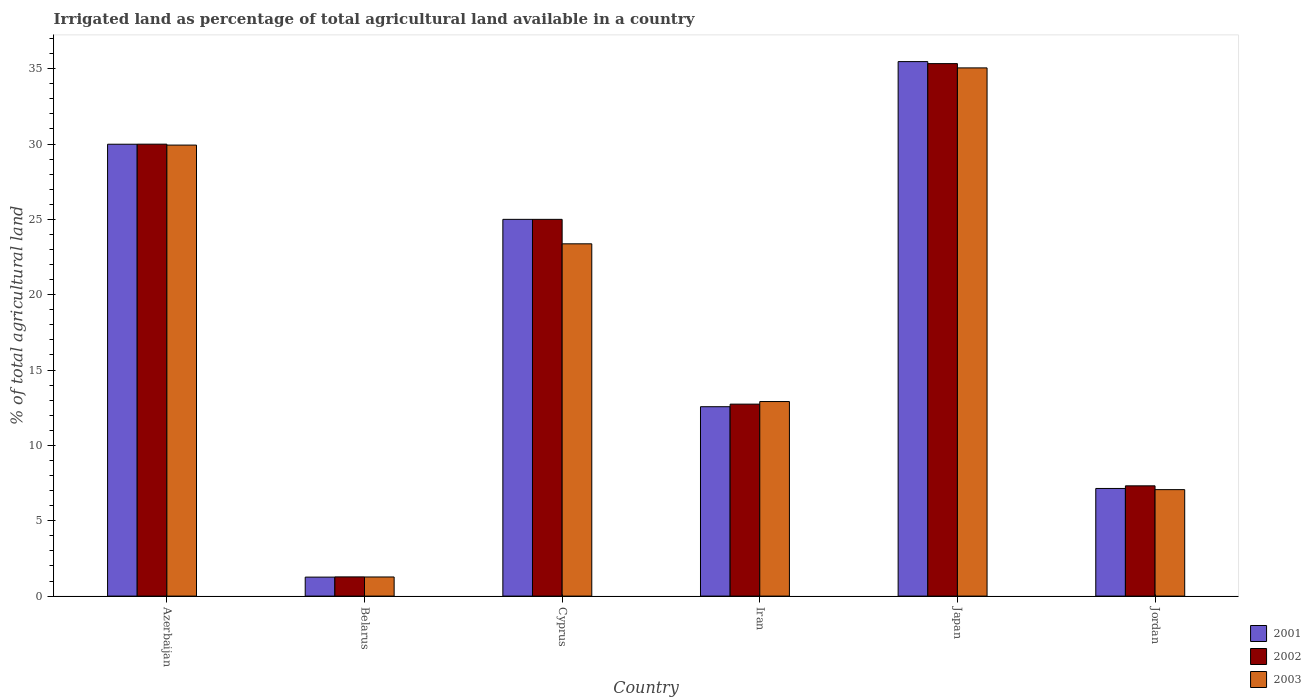How many different coloured bars are there?
Make the answer very short. 3. Are the number of bars on each tick of the X-axis equal?
Offer a very short reply. Yes. How many bars are there on the 6th tick from the right?
Offer a terse response. 3. What is the label of the 1st group of bars from the left?
Provide a succinct answer. Azerbaijan. In how many cases, is the number of bars for a given country not equal to the number of legend labels?
Ensure brevity in your answer.  0. What is the percentage of irrigated land in 2003 in Jordan?
Your response must be concise. 7.06. Across all countries, what is the maximum percentage of irrigated land in 2003?
Provide a short and direct response. 35.05. Across all countries, what is the minimum percentage of irrigated land in 2003?
Give a very brief answer. 1.27. In which country was the percentage of irrigated land in 2003 minimum?
Provide a short and direct response. Belarus. What is the total percentage of irrigated land in 2002 in the graph?
Provide a succinct answer. 111.65. What is the difference between the percentage of irrigated land in 2003 in Iran and that in Japan?
Ensure brevity in your answer.  -22.14. What is the difference between the percentage of irrigated land in 2001 in Cyprus and the percentage of irrigated land in 2002 in Azerbaijan?
Offer a terse response. -4.99. What is the average percentage of irrigated land in 2002 per country?
Your answer should be compact. 18.61. What is the difference between the percentage of irrigated land of/in 2001 and percentage of irrigated land of/in 2002 in Azerbaijan?
Your answer should be very brief. -0. What is the ratio of the percentage of irrigated land in 2003 in Belarus to that in Japan?
Make the answer very short. 0.04. Is the percentage of irrigated land in 2001 in Belarus less than that in Jordan?
Keep it short and to the point. Yes. What is the difference between the highest and the second highest percentage of irrigated land in 2001?
Your answer should be very brief. -10.47. What is the difference between the highest and the lowest percentage of irrigated land in 2003?
Offer a very short reply. 33.78. In how many countries, is the percentage of irrigated land in 2003 greater than the average percentage of irrigated land in 2003 taken over all countries?
Your answer should be compact. 3. What does the 2nd bar from the left in Jordan represents?
Give a very brief answer. 2002. How many bars are there?
Provide a succinct answer. 18. What is the difference between two consecutive major ticks on the Y-axis?
Offer a terse response. 5. Are the values on the major ticks of Y-axis written in scientific E-notation?
Offer a very short reply. No. Does the graph contain any zero values?
Ensure brevity in your answer.  No. Where does the legend appear in the graph?
Your answer should be very brief. Bottom right. What is the title of the graph?
Your answer should be very brief. Irrigated land as percentage of total agricultural land available in a country. What is the label or title of the X-axis?
Offer a very short reply. Country. What is the label or title of the Y-axis?
Keep it short and to the point. % of total agricultural land. What is the % of total agricultural land in 2001 in Azerbaijan?
Provide a succinct answer. 29.99. What is the % of total agricultural land of 2002 in Azerbaijan?
Provide a succinct answer. 29.99. What is the % of total agricultural land of 2003 in Azerbaijan?
Offer a very short reply. 29.93. What is the % of total agricultural land in 2001 in Belarus?
Give a very brief answer. 1.26. What is the % of total agricultural land in 2002 in Belarus?
Offer a very short reply. 1.27. What is the % of total agricultural land of 2003 in Belarus?
Your response must be concise. 1.27. What is the % of total agricultural land in 2002 in Cyprus?
Offer a very short reply. 25. What is the % of total agricultural land in 2003 in Cyprus?
Ensure brevity in your answer.  23.38. What is the % of total agricultural land of 2001 in Iran?
Your answer should be very brief. 12.57. What is the % of total agricultural land in 2002 in Iran?
Make the answer very short. 12.74. What is the % of total agricultural land of 2003 in Iran?
Your response must be concise. 12.91. What is the % of total agricultural land of 2001 in Japan?
Provide a succinct answer. 35.47. What is the % of total agricultural land in 2002 in Japan?
Keep it short and to the point. 35.33. What is the % of total agricultural land in 2003 in Japan?
Offer a very short reply. 35.05. What is the % of total agricultural land of 2001 in Jordan?
Provide a succinct answer. 7.14. What is the % of total agricultural land of 2002 in Jordan?
Your answer should be very brief. 7.32. What is the % of total agricultural land in 2003 in Jordan?
Make the answer very short. 7.06. Across all countries, what is the maximum % of total agricultural land of 2001?
Offer a very short reply. 35.47. Across all countries, what is the maximum % of total agricultural land in 2002?
Offer a terse response. 35.33. Across all countries, what is the maximum % of total agricultural land of 2003?
Give a very brief answer. 35.05. Across all countries, what is the minimum % of total agricultural land of 2001?
Make the answer very short. 1.26. Across all countries, what is the minimum % of total agricultural land of 2002?
Your answer should be compact. 1.27. Across all countries, what is the minimum % of total agricultural land in 2003?
Your answer should be very brief. 1.27. What is the total % of total agricultural land of 2001 in the graph?
Your response must be concise. 111.42. What is the total % of total agricultural land in 2002 in the graph?
Give a very brief answer. 111.65. What is the total % of total agricultural land in 2003 in the graph?
Offer a terse response. 109.6. What is the difference between the % of total agricultural land of 2001 in Azerbaijan and that in Belarus?
Keep it short and to the point. 28.73. What is the difference between the % of total agricultural land of 2002 in Azerbaijan and that in Belarus?
Your response must be concise. 28.72. What is the difference between the % of total agricultural land of 2003 in Azerbaijan and that in Belarus?
Provide a short and direct response. 28.66. What is the difference between the % of total agricultural land of 2001 in Azerbaijan and that in Cyprus?
Provide a succinct answer. 4.99. What is the difference between the % of total agricultural land of 2002 in Azerbaijan and that in Cyprus?
Your response must be concise. 4.99. What is the difference between the % of total agricultural land in 2003 in Azerbaijan and that in Cyprus?
Your answer should be compact. 6.55. What is the difference between the % of total agricultural land in 2001 in Azerbaijan and that in Iran?
Ensure brevity in your answer.  17.42. What is the difference between the % of total agricultural land in 2002 in Azerbaijan and that in Iran?
Keep it short and to the point. 17.25. What is the difference between the % of total agricultural land in 2003 in Azerbaijan and that in Iran?
Offer a terse response. 17.02. What is the difference between the % of total agricultural land in 2001 in Azerbaijan and that in Japan?
Offer a terse response. -5.48. What is the difference between the % of total agricultural land in 2002 in Azerbaijan and that in Japan?
Provide a succinct answer. -5.34. What is the difference between the % of total agricultural land in 2003 in Azerbaijan and that in Japan?
Offer a terse response. -5.12. What is the difference between the % of total agricultural land of 2001 in Azerbaijan and that in Jordan?
Ensure brevity in your answer.  22.84. What is the difference between the % of total agricultural land of 2002 in Azerbaijan and that in Jordan?
Keep it short and to the point. 22.67. What is the difference between the % of total agricultural land of 2003 in Azerbaijan and that in Jordan?
Ensure brevity in your answer.  22.86. What is the difference between the % of total agricultural land of 2001 in Belarus and that in Cyprus?
Your answer should be compact. -23.74. What is the difference between the % of total agricultural land in 2002 in Belarus and that in Cyprus?
Provide a short and direct response. -23.73. What is the difference between the % of total agricultural land in 2003 in Belarus and that in Cyprus?
Give a very brief answer. -22.11. What is the difference between the % of total agricultural land in 2001 in Belarus and that in Iran?
Offer a very short reply. -11.31. What is the difference between the % of total agricultural land in 2002 in Belarus and that in Iran?
Ensure brevity in your answer.  -11.46. What is the difference between the % of total agricultural land of 2003 in Belarus and that in Iran?
Your response must be concise. -11.64. What is the difference between the % of total agricultural land in 2001 in Belarus and that in Japan?
Your response must be concise. -34.21. What is the difference between the % of total agricultural land in 2002 in Belarus and that in Japan?
Keep it short and to the point. -34.06. What is the difference between the % of total agricultural land of 2003 in Belarus and that in Japan?
Your response must be concise. -33.78. What is the difference between the % of total agricultural land of 2001 in Belarus and that in Jordan?
Your response must be concise. -5.88. What is the difference between the % of total agricultural land in 2002 in Belarus and that in Jordan?
Make the answer very short. -6.04. What is the difference between the % of total agricultural land in 2003 in Belarus and that in Jordan?
Provide a succinct answer. -5.8. What is the difference between the % of total agricultural land of 2001 in Cyprus and that in Iran?
Offer a very short reply. 12.43. What is the difference between the % of total agricultural land of 2002 in Cyprus and that in Iran?
Provide a short and direct response. 12.26. What is the difference between the % of total agricultural land in 2003 in Cyprus and that in Iran?
Offer a terse response. 10.47. What is the difference between the % of total agricultural land in 2001 in Cyprus and that in Japan?
Provide a succinct answer. -10.47. What is the difference between the % of total agricultural land of 2002 in Cyprus and that in Japan?
Provide a succinct answer. -10.33. What is the difference between the % of total agricultural land of 2003 in Cyprus and that in Japan?
Ensure brevity in your answer.  -11.67. What is the difference between the % of total agricultural land of 2001 in Cyprus and that in Jordan?
Offer a very short reply. 17.86. What is the difference between the % of total agricultural land of 2002 in Cyprus and that in Jordan?
Your response must be concise. 17.68. What is the difference between the % of total agricultural land in 2003 in Cyprus and that in Jordan?
Keep it short and to the point. 16.31. What is the difference between the % of total agricultural land in 2001 in Iran and that in Japan?
Your answer should be very brief. -22.9. What is the difference between the % of total agricultural land of 2002 in Iran and that in Japan?
Offer a terse response. -22.6. What is the difference between the % of total agricultural land in 2003 in Iran and that in Japan?
Offer a terse response. -22.14. What is the difference between the % of total agricultural land of 2001 in Iran and that in Jordan?
Offer a terse response. 5.42. What is the difference between the % of total agricultural land of 2002 in Iran and that in Jordan?
Provide a succinct answer. 5.42. What is the difference between the % of total agricultural land in 2003 in Iran and that in Jordan?
Make the answer very short. 5.85. What is the difference between the % of total agricultural land in 2001 in Japan and that in Jordan?
Provide a short and direct response. 28.33. What is the difference between the % of total agricultural land in 2002 in Japan and that in Jordan?
Give a very brief answer. 28.02. What is the difference between the % of total agricultural land in 2003 in Japan and that in Jordan?
Your answer should be compact. 27.99. What is the difference between the % of total agricultural land of 2001 in Azerbaijan and the % of total agricultural land of 2002 in Belarus?
Keep it short and to the point. 28.71. What is the difference between the % of total agricultural land of 2001 in Azerbaijan and the % of total agricultural land of 2003 in Belarus?
Offer a very short reply. 28.72. What is the difference between the % of total agricultural land of 2002 in Azerbaijan and the % of total agricultural land of 2003 in Belarus?
Your response must be concise. 28.72. What is the difference between the % of total agricultural land of 2001 in Azerbaijan and the % of total agricultural land of 2002 in Cyprus?
Provide a succinct answer. 4.99. What is the difference between the % of total agricultural land in 2001 in Azerbaijan and the % of total agricultural land in 2003 in Cyprus?
Your answer should be compact. 6.61. What is the difference between the % of total agricultural land in 2002 in Azerbaijan and the % of total agricultural land in 2003 in Cyprus?
Offer a very short reply. 6.61. What is the difference between the % of total agricultural land in 2001 in Azerbaijan and the % of total agricultural land in 2002 in Iran?
Offer a very short reply. 17.25. What is the difference between the % of total agricultural land in 2001 in Azerbaijan and the % of total agricultural land in 2003 in Iran?
Offer a terse response. 17.08. What is the difference between the % of total agricultural land in 2002 in Azerbaijan and the % of total agricultural land in 2003 in Iran?
Your answer should be very brief. 17.08. What is the difference between the % of total agricultural land in 2001 in Azerbaijan and the % of total agricultural land in 2002 in Japan?
Ensure brevity in your answer.  -5.35. What is the difference between the % of total agricultural land in 2001 in Azerbaijan and the % of total agricultural land in 2003 in Japan?
Keep it short and to the point. -5.07. What is the difference between the % of total agricultural land of 2002 in Azerbaijan and the % of total agricultural land of 2003 in Japan?
Offer a terse response. -5.06. What is the difference between the % of total agricultural land of 2001 in Azerbaijan and the % of total agricultural land of 2002 in Jordan?
Provide a succinct answer. 22.67. What is the difference between the % of total agricultural land of 2001 in Azerbaijan and the % of total agricultural land of 2003 in Jordan?
Make the answer very short. 22.92. What is the difference between the % of total agricultural land of 2002 in Azerbaijan and the % of total agricultural land of 2003 in Jordan?
Your answer should be compact. 22.93. What is the difference between the % of total agricultural land in 2001 in Belarus and the % of total agricultural land in 2002 in Cyprus?
Your answer should be compact. -23.74. What is the difference between the % of total agricultural land in 2001 in Belarus and the % of total agricultural land in 2003 in Cyprus?
Provide a short and direct response. -22.12. What is the difference between the % of total agricultural land of 2002 in Belarus and the % of total agricultural land of 2003 in Cyprus?
Your response must be concise. -22.1. What is the difference between the % of total agricultural land of 2001 in Belarus and the % of total agricultural land of 2002 in Iran?
Your answer should be very brief. -11.48. What is the difference between the % of total agricultural land in 2001 in Belarus and the % of total agricultural land in 2003 in Iran?
Your answer should be compact. -11.65. What is the difference between the % of total agricultural land of 2002 in Belarus and the % of total agricultural land of 2003 in Iran?
Ensure brevity in your answer.  -11.64. What is the difference between the % of total agricultural land in 2001 in Belarus and the % of total agricultural land in 2002 in Japan?
Provide a short and direct response. -34.08. What is the difference between the % of total agricultural land in 2001 in Belarus and the % of total agricultural land in 2003 in Japan?
Provide a short and direct response. -33.79. What is the difference between the % of total agricultural land in 2002 in Belarus and the % of total agricultural land in 2003 in Japan?
Your answer should be compact. -33.78. What is the difference between the % of total agricultural land of 2001 in Belarus and the % of total agricultural land of 2002 in Jordan?
Your response must be concise. -6.06. What is the difference between the % of total agricultural land in 2001 in Belarus and the % of total agricultural land in 2003 in Jordan?
Your response must be concise. -5.8. What is the difference between the % of total agricultural land of 2002 in Belarus and the % of total agricultural land of 2003 in Jordan?
Your response must be concise. -5.79. What is the difference between the % of total agricultural land of 2001 in Cyprus and the % of total agricultural land of 2002 in Iran?
Ensure brevity in your answer.  12.26. What is the difference between the % of total agricultural land of 2001 in Cyprus and the % of total agricultural land of 2003 in Iran?
Your answer should be compact. 12.09. What is the difference between the % of total agricultural land in 2002 in Cyprus and the % of total agricultural land in 2003 in Iran?
Your answer should be very brief. 12.09. What is the difference between the % of total agricultural land in 2001 in Cyprus and the % of total agricultural land in 2002 in Japan?
Offer a terse response. -10.33. What is the difference between the % of total agricultural land in 2001 in Cyprus and the % of total agricultural land in 2003 in Japan?
Your answer should be compact. -10.05. What is the difference between the % of total agricultural land in 2002 in Cyprus and the % of total agricultural land in 2003 in Japan?
Provide a short and direct response. -10.05. What is the difference between the % of total agricultural land in 2001 in Cyprus and the % of total agricultural land in 2002 in Jordan?
Your answer should be compact. 17.68. What is the difference between the % of total agricultural land in 2001 in Cyprus and the % of total agricultural land in 2003 in Jordan?
Your response must be concise. 17.94. What is the difference between the % of total agricultural land of 2002 in Cyprus and the % of total agricultural land of 2003 in Jordan?
Your response must be concise. 17.94. What is the difference between the % of total agricultural land of 2001 in Iran and the % of total agricultural land of 2002 in Japan?
Keep it short and to the point. -22.77. What is the difference between the % of total agricultural land of 2001 in Iran and the % of total agricultural land of 2003 in Japan?
Make the answer very short. -22.48. What is the difference between the % of total agricultural land of 2002 in Iran and the % of total agricultural land of 2003 in Japan?
Your response must be concise. -22.31. What is the difference between the % of total agricultural land of 2001 in Iran and the % of total agricultural land of 2002 in Jordan?
Your response must be concise. 5.25. What is the difference between the % of total agricultural land of 2001 in Iran and the % of total agricultural land of 2003 in Jordan?
Provide a short and direct response. 5.5. What is the difference between the % of total agricultural land of 2002 in Iran and the % of total agricultural land of 2003 in Jordan?
Offer a very short reply. 5.67. What is the difference between the % of total agricultural land of 2001 in Japan and the % of total agricultural land of 2002 in Jordan?
Your answer should be very brief. 28.15. What is the difference between the % of total agricultural land of 2001 in Japan and the % of total agricultural land of 2003 in Jordan?
Your answer should be very brief. 28.4. What is the difference between the % of total agricultural land of 2002 in Japan and the % of total agricultural land of 2003 in Jordan?
Ensure brevity in your answer.  28.27. What is the average % of total agricultural land in 2001 per country?
Your answer should be very brief. 18.57. What is the average % of total agricultural land in 2002 per country?
Keep it short and to the point. 18.61. What is the average % of total agricultural land in 2003 per country?
Your answer should be compact. 18.27. What is the difference between the % of total agricultural land of 2001 and % of total agricultural land of 2002 in Azerbaijan?
Offer a terse response. -0. What is the difference between the % of total agricultural land of 2001 and % of total agricultural land of 2003 in Azerbaijan?
Your response must be concise. 0.06. What is the difference between the % of total agricultural land in 2002 and % of total agricultural land in 2003 in Azerbaijan?
Ensure brevity in your answer.  0.06. What is the difference between the % of total agricultural land of 2001 and % of total agricultural land of 2002 in Belarus?
Your response must be concise. -0.01. What is the difference between the % of total agricultural land of 2001 and % of total agricultural land of 2003 in Belarus?
Your answer should be very brief. -0.01. What is the difference between the % of total agricultural land in 2002 and % of total agricultural land in 2003 in Belarus?
Make the answer very short. 0.01. What is the difference between the % of total agricultural land of 2001 and % of total agricultural land of 2003 in Cyprus?
Give a very brief answer. 1.62. What is the difference between the % of total agricultural land in 2002 and % of total agricultural land in 2003 in Cyprus?
Provide a succinct answer. 1.62. What is the difference between the % of total agricultural land of 2001 and % of total agricultural land of 2002 in Iran?
Provide a short and direct response. -0.17. What is the difference between the % of total agricultural land in 2001 and % of total agricultural land in 2003 in Iran?
Offer a very short reply. -0.34. What is the difference between the % of total agricultural land in 2002 and % of total agricultural land in 2003 in Iran?
Your response must be concise. -0.17. What is the difference between the % of total agricultural land in 2001 and % of total agricultural land in 2002 in Japan?
Provide a succinct answer. 0.13. What is the difference between the % of total agricultural land in 2001 and % of total agricultural land in 2003 in Japan?
Provide a succinct answer. 0.42. What is the difference between the % of total agricultural land of 2002 and % of total agricultural land of 2003 in Japan?
Keep it short and to the point. 0.28. What is the difference between the % of total agricultural land in 2001 and % of total agricultural land in 2002 in Jordan?
Ensure brevity in your answer.  -0.17. What is the difference between the % of total agricultural land of 2001 and % of total agricultural land of 2003 in Jordan?
Give a very brief answer. 0.08. What is the difference between the % of total agricultural land of 2002 and % of total agricultural land of 2003 in Jordan?
Your response must be concise. 0.25. What is the ratio of the % of total agricultural land in 2001 in Azerbaijan to that in Belarus?
Provide a succinct answer. 23.8. What is the ratio of the % of total agricultural land of 2002 in Azerbaijan to that in Belarus?
Give a very brief answer. 23.54. What is the ratio of the % of total agricultural land of 2003 in Azerbaijan to that in Belarus?
Your answer should be compact. 23.59. What is the ratio of the % of total agricultural land in 2001 in Azerbaijan to that in Cyprus?
Your answer should be very brief. 1.2. What is the ratio of the % of total agricultural land in 2002 in Azerbaijan to that in Cyprus?
Provide a short and direct response. 1.2. What is the ratio of the % of total agricultural land of 2003 in Azerbaijan to that in Cyprus?
Keep it short and to the point. 1.28. What is the ratio of the % of total agricultural land in 2001 in Azerbaijan to that in Iran?
Ensure brevity in your answer.  2.39. What is the ratio of the % of total agricultural land in 2002 in Azerbaijan to that in Iran?
Your response must be concise. 2.35. What is the ratio of the % of total agricultural land of 2003 in Azerbaijan to that in Iran?
Your answer should be compact. 2.32. What is the ratio of the % of total agricultural land in 2001 in Azerbaijan to that in Japan?
Offer a very short reply. 0.85. What is the ratio of the % of total agricultural land of 2002 in Azerbaijan to that in Japan?
Offer a very short reply. 0.85. What is the ratio of the % of total agricultural land of 2003 in Azerbaijan to that in Japan?
Offer a very short reply. 0.85. What is the ratio of the % of total agricultural land of 2001 in Azerbaijan to that in Jordan?
Ensure brevity in your answer.  4.2. What is the ratio of the % of total agricultural land in 2002 in Azerbaijan to that in Jordan?
Your response must be concise. 4.1. What is the ratio of the % of total agricultural land in 2003 in Azerbaijan to that in Jordan?
Give a very brief answer. 4.24. What is the ratio of the % of total agricultural land in 2001 in Belarus to that in Cyprus?
Your answer should be compact. 0.05. What is the ratio of the % of total agricultural land in 2002 in Belarus to that in Cyprus?
Make the answer very short. 0.05. What is the ratio of the % of total agricultural land in 2003 in Belarus to that in Cyprus?
Your response must be concise. 0.05. What is the ratio of the % of total agricultural land of 2001 in Belarus to that in Iran?
Ensure brevity in your answer.  0.1. What is the ratio of the % of total agricultural land in 2002 in Belarus to that in Iran?
Provide a short and direct response. 0.1. What is the ratio of the % of total agricultural land in 2003 in Belarus to that in Iran?
Offer a very short reply. 0.1. What is the ratio of the % of total agricultural land in 2001 in Belarus to that in Japan?
Your answer should be very brief. 0.04. What is the ratio of the % of total agricultural land in 2002 in Belarus to that in Japan?
Provide a short and direct response. 0.04. What is the ratio of the % of total agricultural land in 2003 in Belarus to that in Japan?
Make the answer very short. 0.04. What is the ratio of the % of total agricultural land in 2001 in Belarus to that in Jordan?
Your answer should be compact. 0.18. What is the ratio of the % of total agricultural land in 2002 in Belarus to that in Jordan?
Your response must be concise. 0.17. What is the ratio of the % of total agricultural land of 2003 in Belarus to that in Jordan?
Your response must be concise. 0.18. What is the ratio of the % of total agricultural land in 2001 in Cyprus to that in Iran?
Make the answer very short. 1.99. What is the ratio of the % of total agricultural land in 2002 in Cyprus to that in Iran?
Provide a succinct answer. 1.96. What is the ratio of the % of total agricultural land in 2003 in Cyprus to that in Iran?
Provide a short and direct response. 1.81. What is the ratio of the % of total agricultural land in 2001 in Cyprus to that in Japan?
Your answer should be compact. 0.7. What is the ratio of the % of total agricultural land of 2002 in Cyprus to that in Japan?
Provide a short and direct response. 0.71. What is the ratio of the % of total agricultural land in 2003 in Cyprus to that in Japan?
Offer a very short reply. 0.67. What is the ratio of the % of total agricultural land in 2001 in Cyprus to that in Jordan?
Give a very brief answer. 3.5. What is the ratio of the % of total agricultural land of 2002 in Cyprus to that in Jordan?
Your answer should be compact. 3.42. What is the ratio of the % of total agricultural land of 2003 in Cyprus to that in Jordan?
Keep it short and to the point. 3.31. What is the ratio of the % of total agricultural land of 2001 in Iran to that in Japan?
Provide a short and direct response. 0.35. What is the ratio of the % of total agricultural land in 2002 in Iran to that in Japan?
Provide a succinct answer. 0.36. What is the ratio of the % of total agricultural land of 2003 in Iran to that in Japan?
Your answer should be very brief. 0.37. What is the ratio of the % of total agricultural land in 2001 in Iran to that in Jordan?
Provide a short and direct response. 1.76. What is the ratio of the % of total agricultural land in 2002 in Iran to that in Jordan?
Offer a very short reply. 1.74. What is the ratio of the % of total agricultural land of 2003 in Iran to that in Jordan?
Offer a very short reply. 1.83. What is the ratio of the % of total agricultural land of 2001 in Japan to that in Jordan?
Your answer should be compact. 4.97. What is the ratio of the % of total agricultural land in 2002 in Japan to that in Jordan?
Keep it short and to the point. 4.83. What is the ratio of the % of total agricultural land in 2003 in Japan to that in Jordan?
Make the answer very short. 4.96. What is the difference between the highest and the second highest % of total agricultural land in 2001?
Offer a very short reply. 5.48. What is the difference between the highest and the second highest % of total agricultural land of 2002?
Your response must be concise. 5.34. What is the difference between the highest and the second highest % of total agricultural land of 2003?
Keep it short and to the point. 5.12. What is the difference between the highest and the lowest % of total agricultural land of 2001?
Give a very brief answer. 34.21. What is the difference between the highest and the lowest % of total agricultural land in 2002?
Your answer should be very brief. 34.06. What is the difference between the highest and the lowest % of total agricultural land in 2003?
Your answer should be very brief. 33.78. 